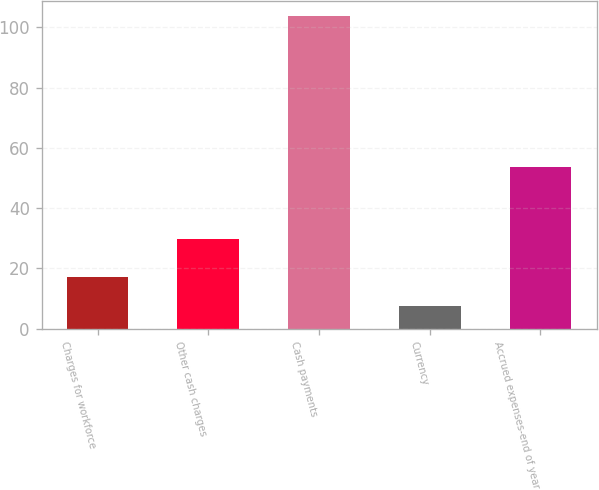Convert chart. <chart><loc_0><loc_0><loc_500><loc_500><bar_chart><fcel>Charges for workforce<fcel>Other cash charges<fcel>Cash payments<fcel>Currency<fcel>Accrued expenses-end of year<nl><fcel>17.21<fcel>29.9<fcel>103.7<fcel>7.6<fcel>53.8<nl></chart> 